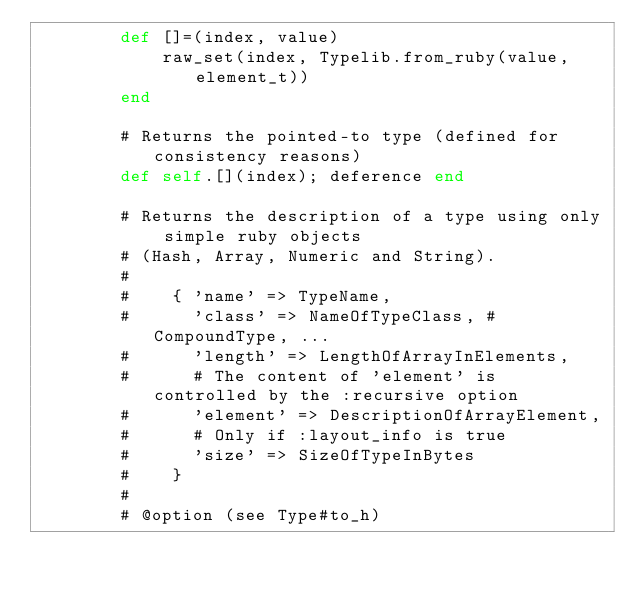Convert code to text. <code><loc_0><loc_0><loc_500><loc_500><_Ruby_>        def []=(index, value)
            raw_set(index, Typelib.from_ruby(value, element_t))
        end

        # Returns the pointed-to type (defined for consistency reasons)
        def self.[](index); deference end

        # Returns the description of a type using only simple ruby objects
        # (Hash, Array, Numeric and String).
        #
        #    { 'name' => TypeName,
        #      'class' => NameOfTypeClass, # CompoundType, ...
        #      'length' => LengthOfArrayInElements,
        #      # The content of 'element' is controlled by the :recursive option
        #      'element' => DescriptionOfArrayElement,
        #      # Only if :layout_info is true
        #      'size' => SizeOfTypeInBytes
        #    }
        #
        # @option (see Type#to_h)</code> 